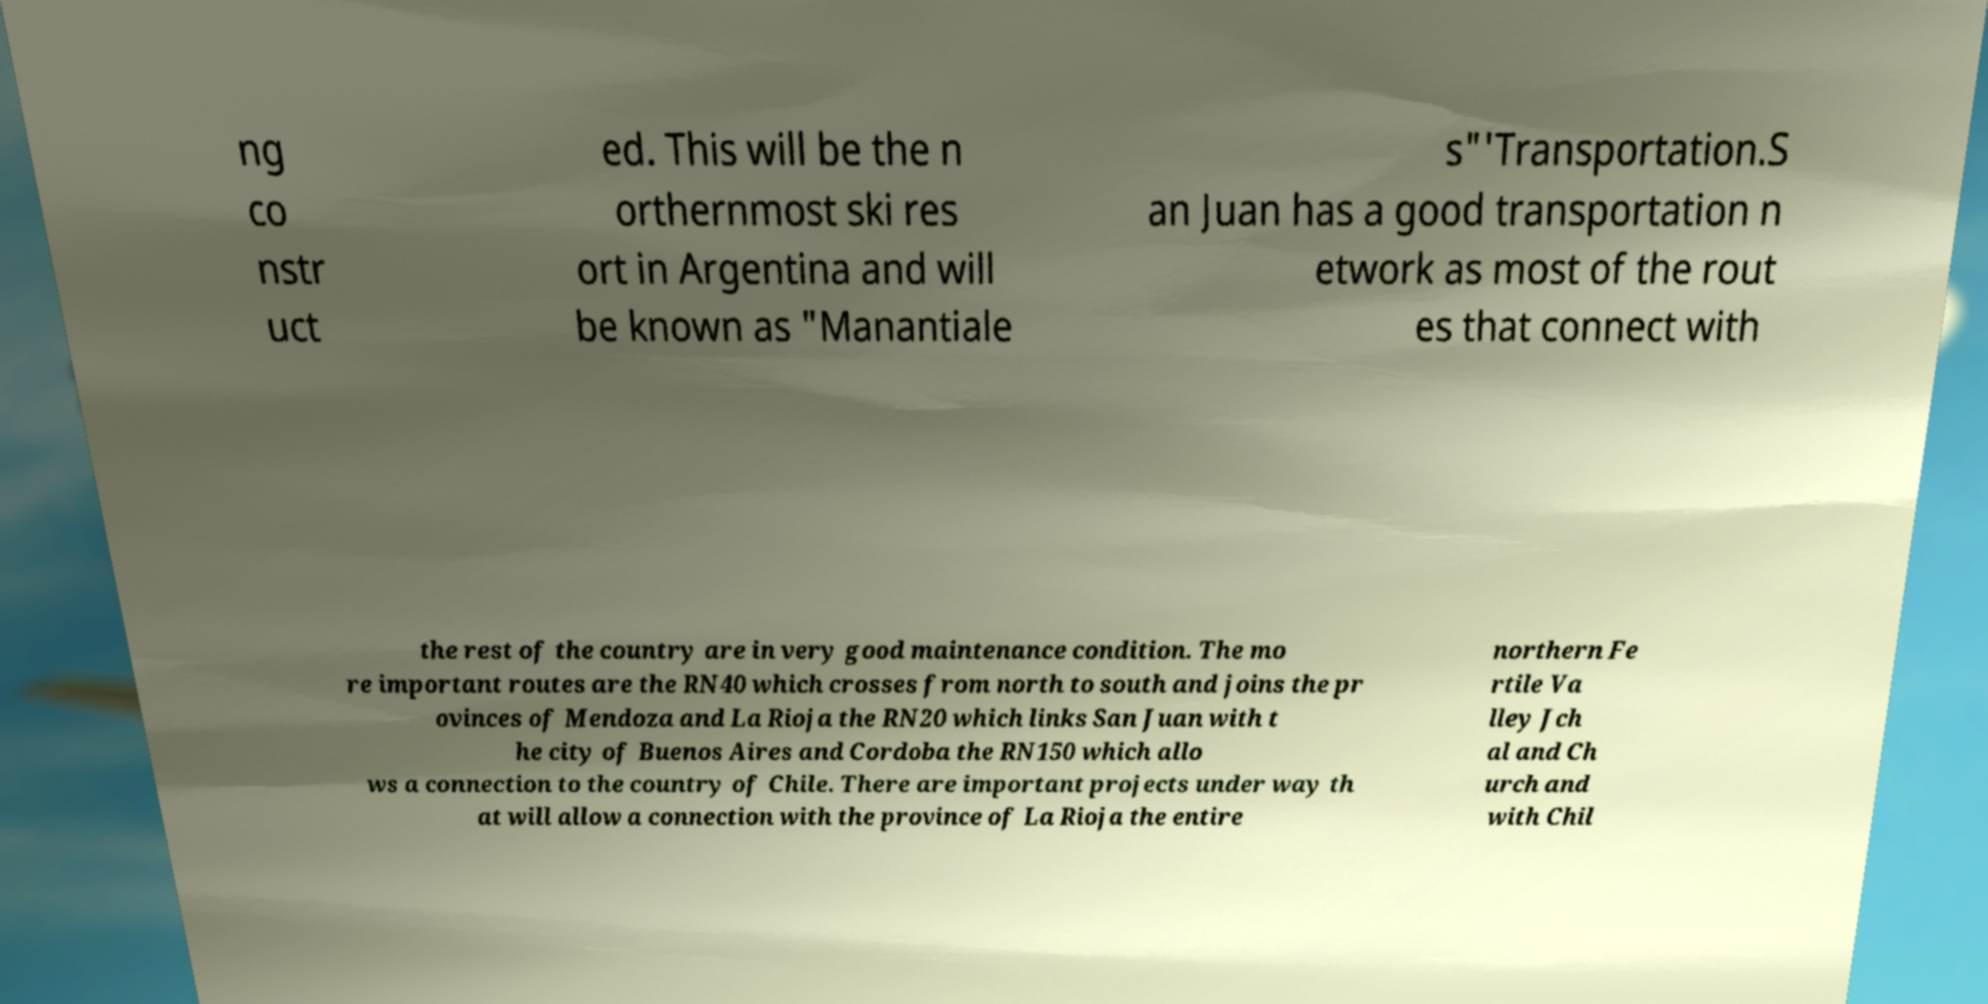Could you extract and type out the text from this image? ng co nstr uct ed. This will be the n orthernmost ski res ort in Argentina and will be known as "Manantiale s"'Transportation.S an Juan has a good transportation n etwork as most of the rout es that connect with the rest of the country are in very good maintenance condition. The mo re important routes are the RN40 which crosses from north to south and joins the pr ovinces of Mendoza and La Rioja the RN20 which links San Juan with t he city of Buenos Aires and Cordoba the RN150 which allo ws a connection to the country of Chile. There are important projects under way th at will allow a connection with the province of La Rioja the entire northern Fe rtile Va lley Jch al and Ch urch and with Chil 